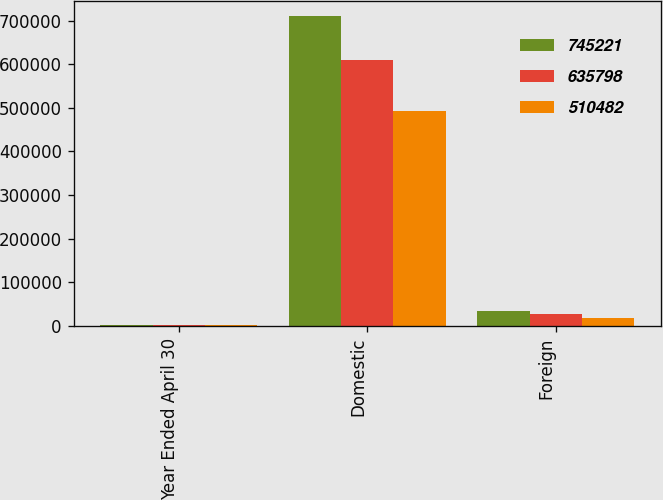Convert chart to OTSL. <chart><loc_0><loc_0><loc_500><loc_500><stacked_bar_chart><ecel><fcel>Year Ended April 30<fcel>Domestic<fcel>Foreign<nl><fcel>745221<fcel>2008<fcel>710312<fcel>34909<nl><fcel>635798<fcel>2007<fcel>609501<fcel>26297<nl><fcel>510482<fcel>2006<fcel>491758<fcel>18724<nl></chart> 